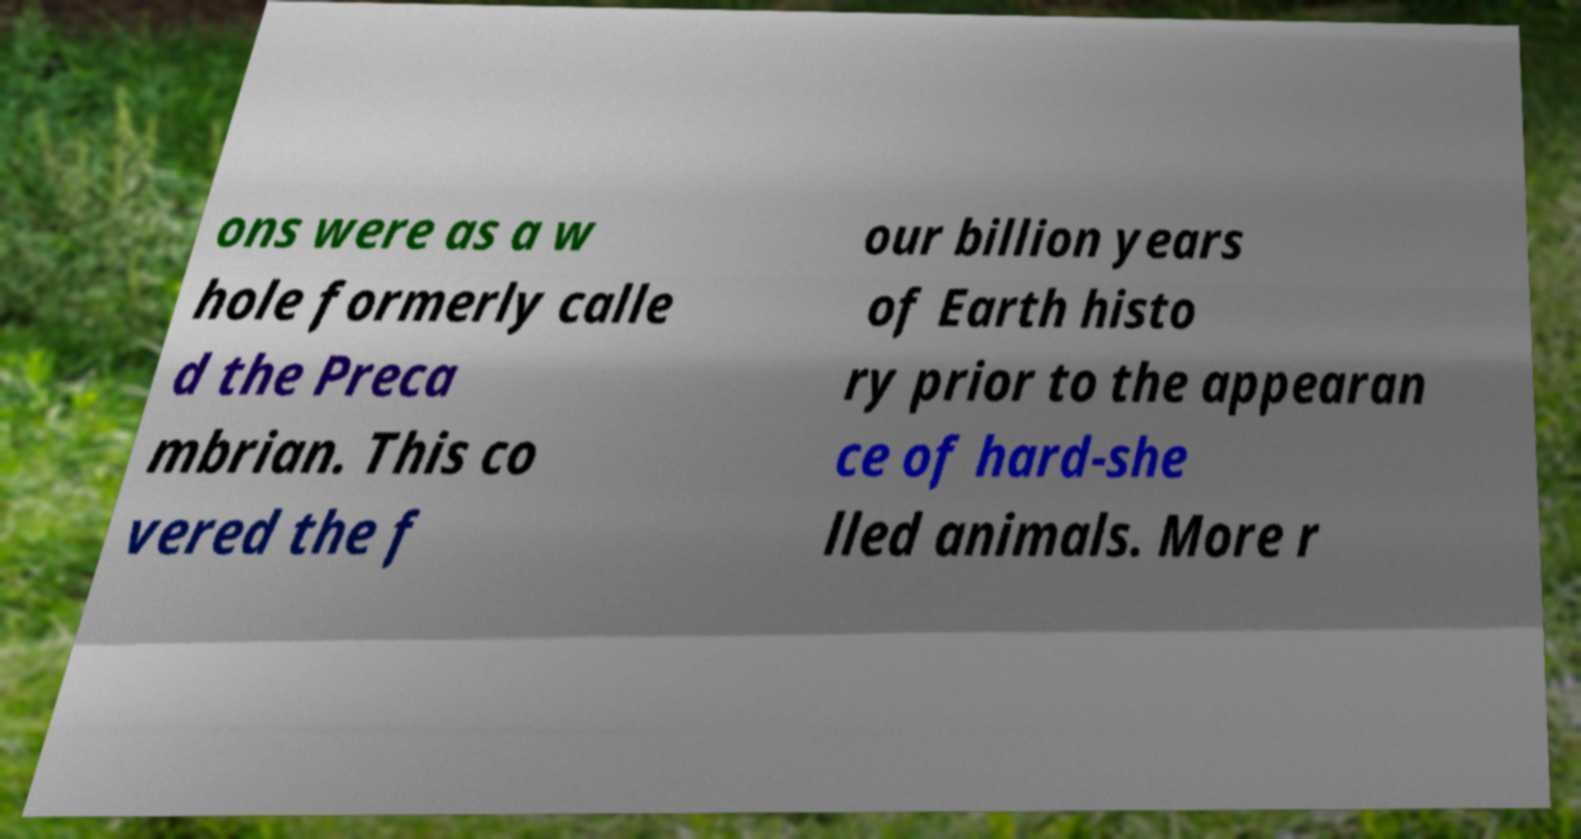Can you accurately transcribe the text from the provided image for me? ons were as a w hole formerly calle d the Preca mbrian. This co vered the f our billion years of Earth histo ry prior to the appearan ce of hard-she lled animals. More r 